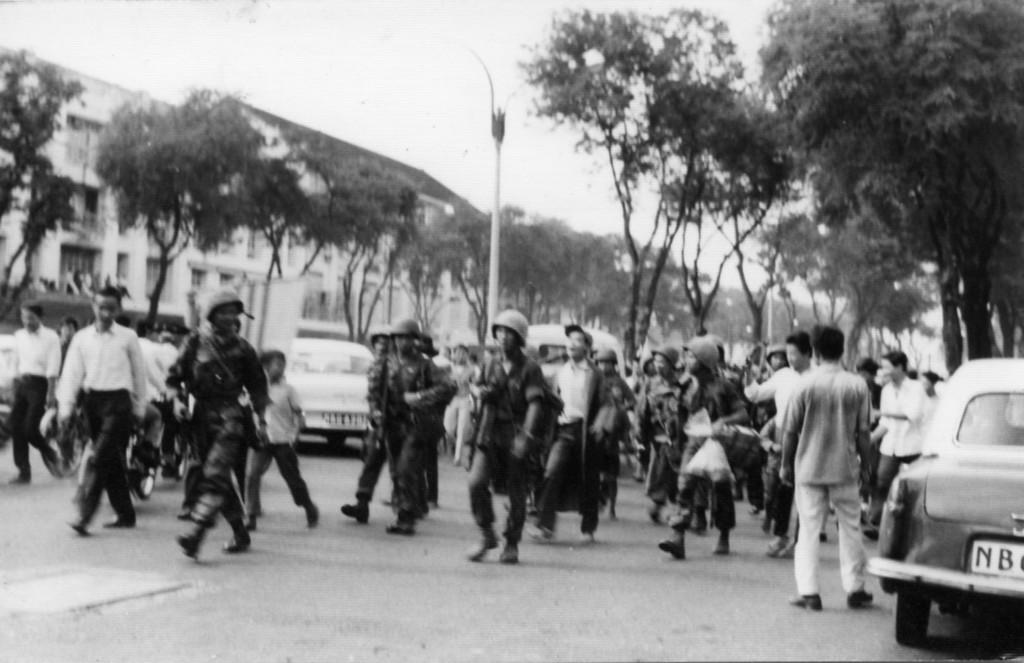What are the people in the center of the image doing? Some people are walking, and some are standing in the center of the image. What can be seen on the road in the image? There are cars on the road. What is visible in the background of the image? There are trees, a pole, buildings, and the sky visible in the background of the image. Can you see any examples of toes in the image? There are no toes visible in the image. What type of beam is holding up the buildings in the image? The image does not provide enough detail to determine the type of beam holding up the buildings. 